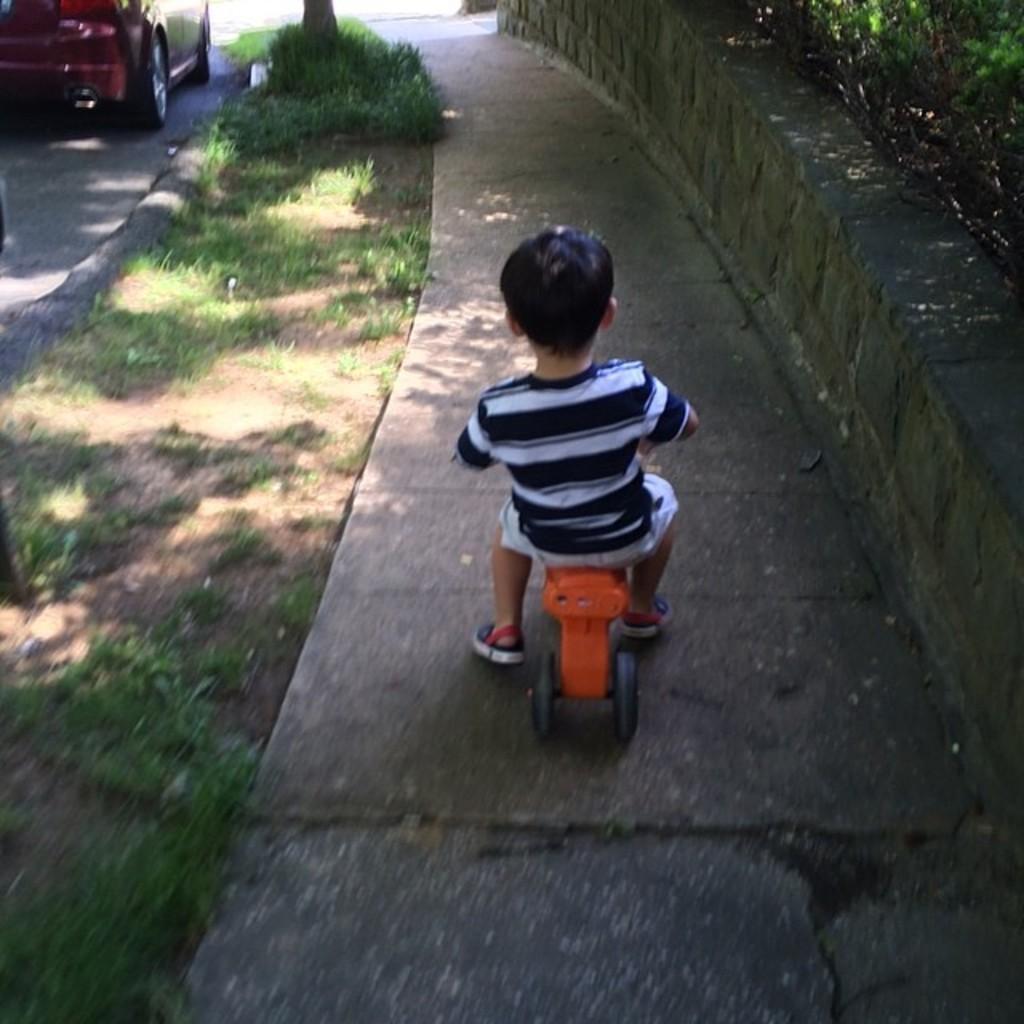Describe this image in one or two sentences. In this picture I can see there is a kid riding a bicycle on the walk way and there is a car parked here and there are plants on right. 